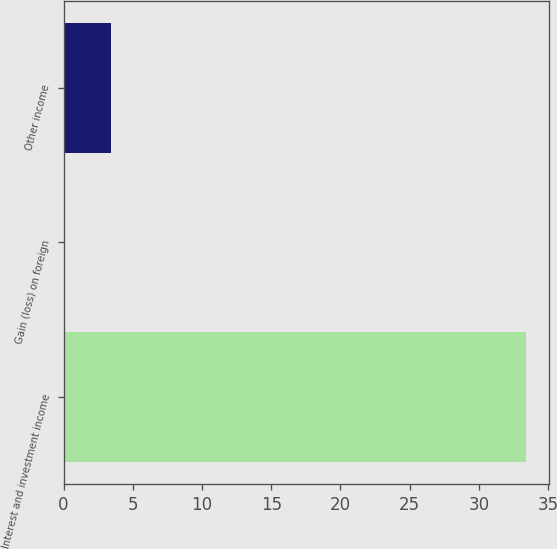Convert chart. <chart><loc_0><loc_0><loc_500><loc_500><bar_chart><fcel>Interest and investment income<fcel>Gain (loss) on foreign<fcel>Other income<nl><fcel>33.4<fcel>0.1<fcel>3.43<nl></chart> 